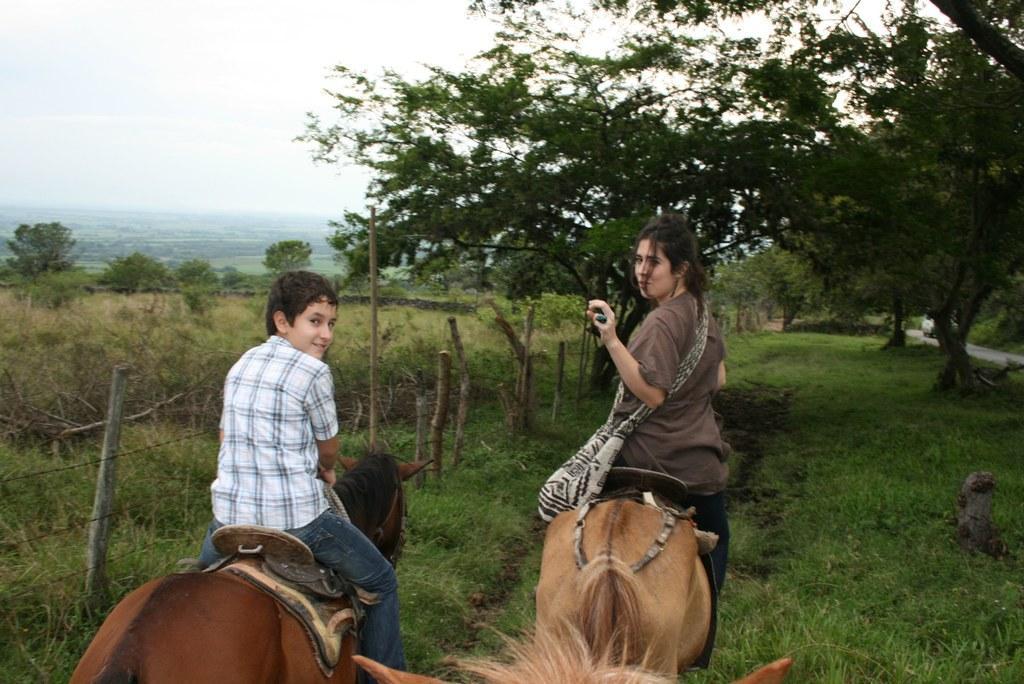Describe this image in one or two sentences. The image is outside of the city. In the image there are two people one woman and a boy sitting on horse and riding a horse. In background we can see some trees and sky is on top. 